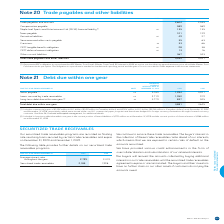According to Bce's financial document, How are the notes payable hedged? hedged for foreign currency fluctuations through forward currency contracts. The document states: "r our U.S. commercial paper program and have been hedged for foreign currency fluctuations through forward currency contracts. See Note 26, Financial ..." Also, How are the commercial papers issued? issued under our U.S. commercial paper program. The document states: "9 and December 31, 2018, respectively, which were issued under our U.S. commercial paper program and have been hedged for foreign currency fluctuation..." Also, Which currencies are referenced in the context? The document shows two values: U.S. dollars and Canadian dollars. From the document: "$1,502 million in U.S. dollars ($1,951 million in Canadian dollars) and $2,314 million in U.S. dollars ($3,156 million in Canadian dollars) as at Dece..." Also, can you calculate: What is the total long-term debt due within one year in 2018 and 2019? Based on the calculation: 837+525, the result is 1362. This is based on the information: "ng-term debt due within one year (2) 22 4.77% 837 525 Long-term debt due within one year (2) 22 4.77% 837 525..." The key data points involved are: 525, 837. Also, can you calculate: What is the difference in the weighted average interest rate for notes payable and loans secured by trade receivables? Based on the calculation: 2.71%-2.03%, the result is 0.68 (percentage). This is based on the information: "Loans secured by trade receivables 26 2.71% 1,050 919 Notes payable (1) 26 2.03% 1,994 3,201..." The key data points involved are: 2.03, 2.71. Also, can you calculate: What is the percentage change in the total debt due within one year in 2019? To answer this question, I need to perform calculations using the financial data. The calculation is: (3,881-4,645)/4,645, which equals -16.45 (percentage). This is based on the information: "Total debt due within one year 3,881 4,645 Total debt due within one year 3,881 4,645..." The key data points involved are: 3,881, 4,645. 